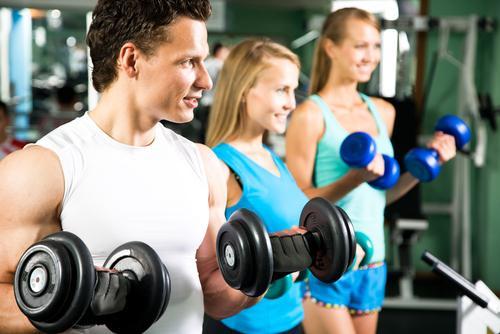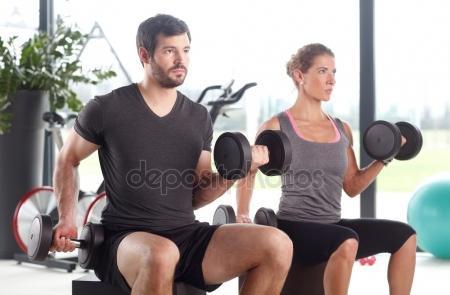The first image is the image on the left, the second image is the image on the right. Considering the images on both sides, is "The right image includes two people sitting facing forward, each with one dumbbell in a lowered hand and one in a raised hand." valid? Answer yes or no. Yes. 